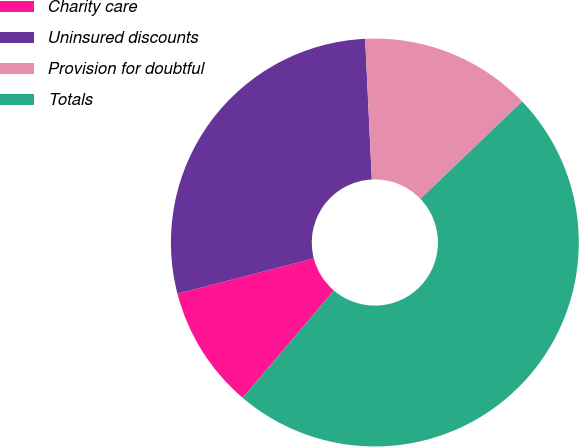Convert chart. <chart><loc_0><loc_0><loc_500><loc_500><pie_chart><fcel>Charity care<fcel>Uninsured discounts<fcel>Provision for doubtful<fcel>Totals<nl><fcel>9.74%<fcel>28.28%<fcel>13.6%<fcel>48.37%<nl></chart> 